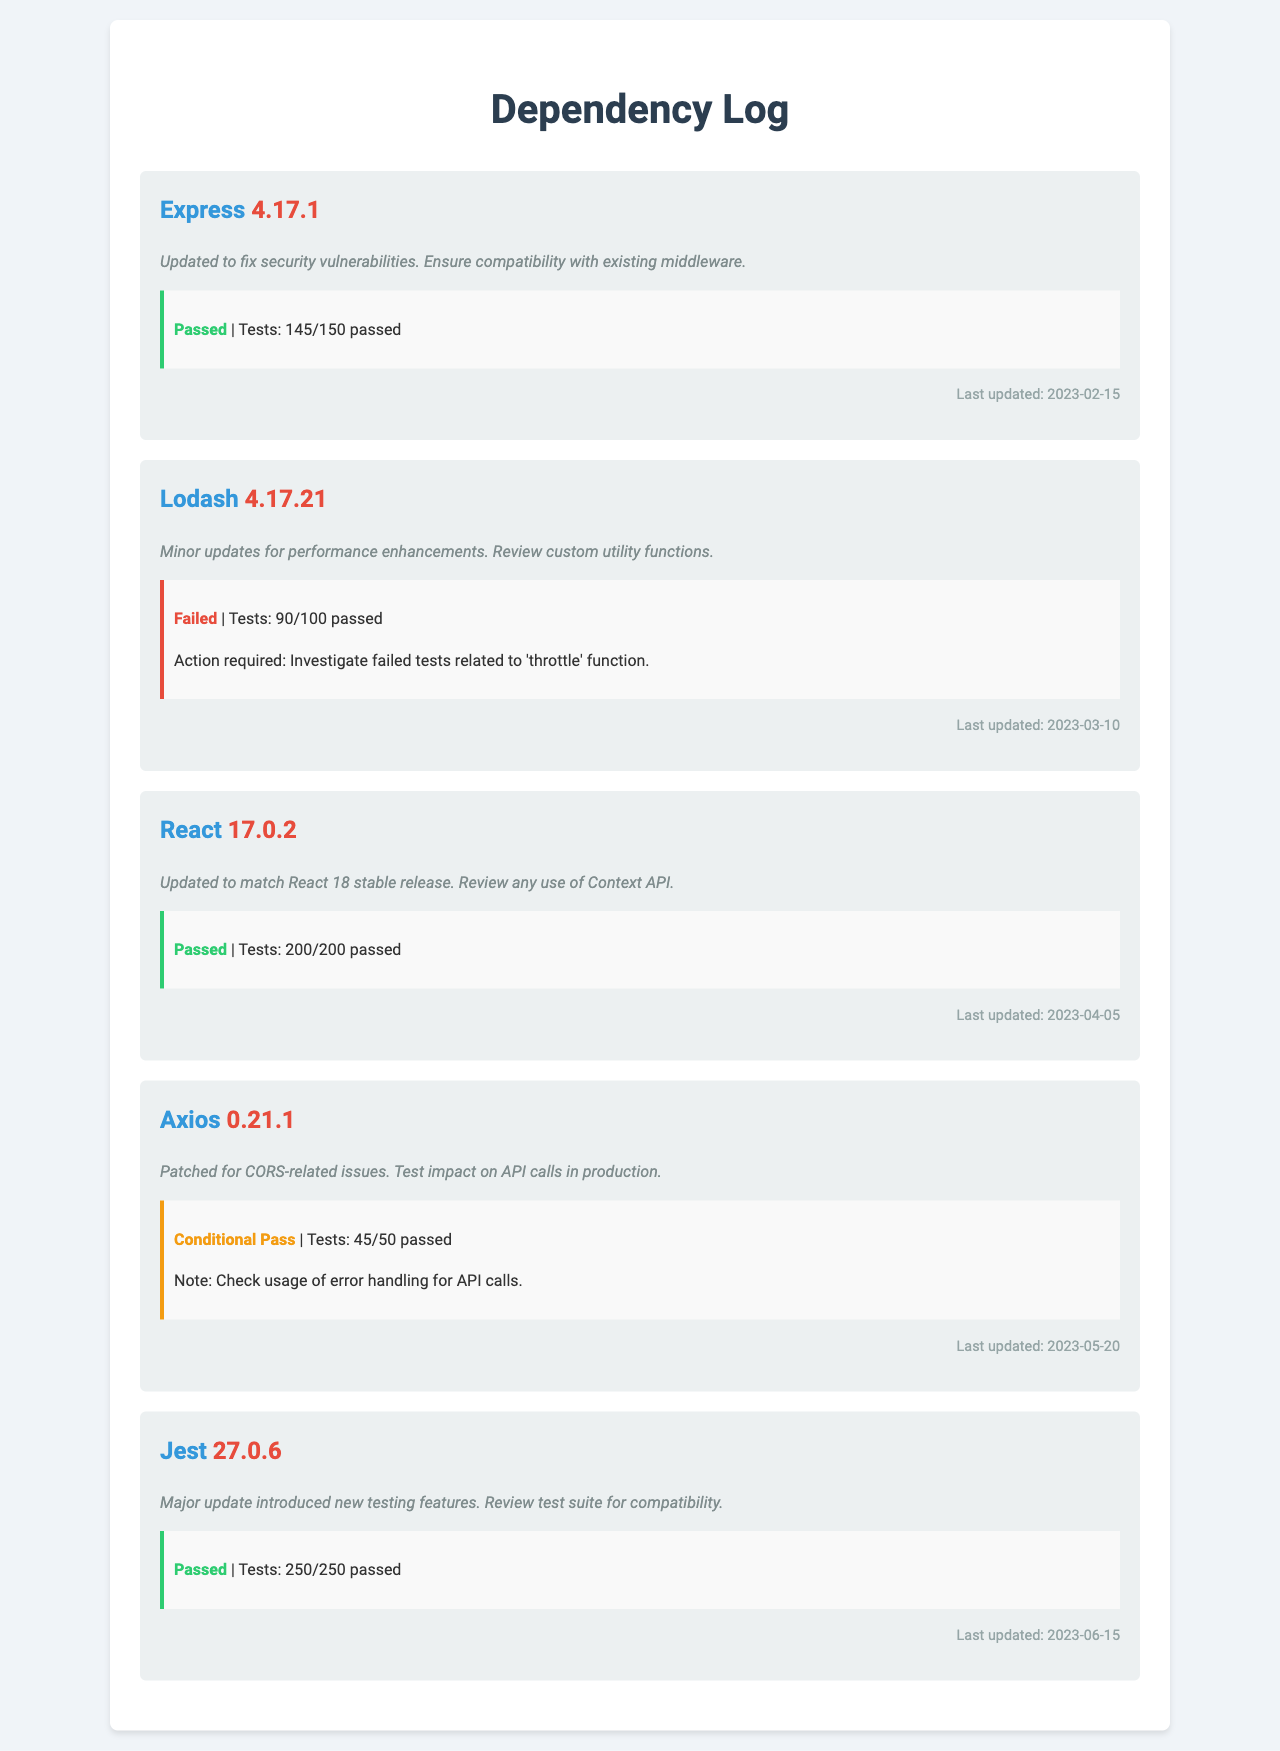What is the version of Express? The document lists the version of Express as 4.17.1.
Answer: 4.17.1 What is the last updated date for Lodash? The last updated date for Lodash is mentioned as 2023-03-10.
Answer: 2023-03-10 How many tests did React pass? The document states that React passed all its tests with a count of 200/200.
Answer: 200/200 What is the status of the verification for Axios? Axios has a conditional pass status according to the verification section.
Answer: Conditional Pass What was the main reason for the update to Jest? The main reason for updating Jest was the introduction of new testing features.
Answer: New testing features What issue was addressed in the latest update of Axios? The latest update for Axios patched CORS-related issues.
Answer: CORS-related issues How many tests failed in Lodash? The document indicates that Lodash had 10 tests that failed out of 100.
Answer: 10 What is the last updated date for Jest? The last updated date for Jest is provided as 2023-06-15.
Answer: 2023-06-15 What needed investigation in Lodash? The document notes that investigation is required for failed tests related to the 'throttle' function.
Answer: 'throttle' function 